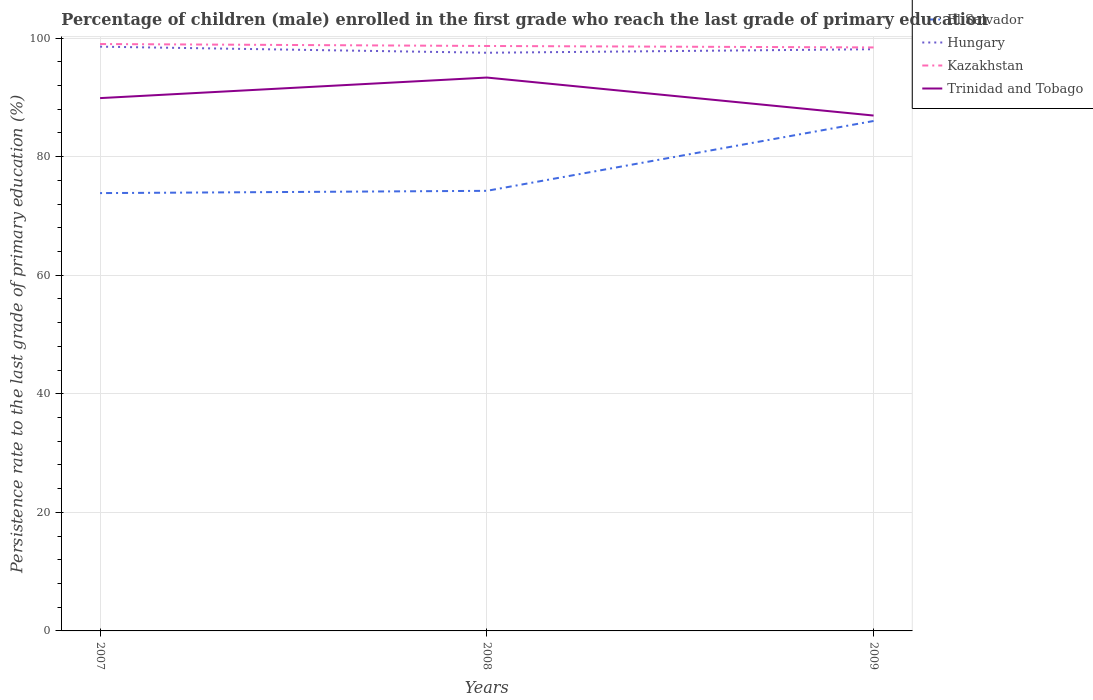How many different coloured lines are there?
Offer a terse response. 4. Does the line corresponding to El Salvador intersect with the line corresponding to Trinidad and Tobago?
Your answer should be compact. No. Across all years, what is the maximum persistence rate of children in Hungary?
Your response must be concise. 97.53. What is the total persistence rate of children in Kazakhstan in the graph?
Ensure brevity in your answer.  0.25. What is the difference between the highest and the second highest persistence rate of children in Kazakhstan?
Give a very brief answer. 0.57. Are the values on the major ticks of Y-axis written in scientific E-notation?
Ensure brevity in your answer.  No. Does the graph contain any zero values?
Offer a terse response. No. What is the title of the graph?
Make the answer very short. Percentage of children (male) enrolled in the first grade who reach the last grade of primary education. Does "Malta" appear as one of the legend labels in the graph?
Offer a very short reply. No. What is the label or title of the X-axis?
Provide a short and direct response. Years. What is the label or title of the Y-axis?
Ensure brevity in your answer.  Persistence rate to the last grade of primary education (%). What is the Persistence rate to the last grade of primary education (%) in El Salvador in 2007?
Your response must be concise. 73.85. What is the Persistence rate to the last grade of primary education (%) in Hungary in 2007?
Make the answer very short. 98.56. What is the Persistence rate to the last grade of primary education (%) in Kazakhstan in 2007?
Offer a very short reply. 99. What is the Persistence rate to the last grade of primary education (%) in Trinidad and Tobago in 2007?
Your answer should be very brief. 89.88. What is the Persistence rate to the last grade of primary education (%) of El Salvador in 2008?
Your answer should be very brief. 74.24. What is the Persistence rate to the last grade of primary education (%) in Hungary in 2008?
Give a very brief answer. 97.53. What is the Persistence rate to the last grade of primary education (%) of Kazakhstan in 2008?
Keep it short and to the point. 98.67. What is the Persistence rate to the last grade of primary education (%) in Trinidad and Tobago in 2008?
Make the answer very short. 93.35. What is the Persistence rate to the last grade of primary education (%) of El Salvador in 2009?
Give a very brief answer. 86.02. What is the Persistence rate to the last grade of primary education (%) of Hungary in 2009?
Ensure brevity in your answer.  98.12. What is the Persistence rate to the last grade of primary education (%) in Kazakhstan in 2009?
Offer a terse response. 98.42. What is the Persistence rate to the last grade of primary education (%) in Trinidad and Tobago in 2009?
Your answer should be very brief. 86.94. Across all years, what is the maximum Persistence rate to the last grade of primary education (%) of El Salvador?
Your response must be concise. 86.02. Across all years, what is the maximum Persistence rate to the last grade of primary education (%) of Hungary?
Give a very brief answer. 98.56. Across all years, what is the maximum Persistence rate to the last grade of primary education (%) in Kazakhstan?
Offer a very short reply. 99. Across all years, what is the maximum Persistence rate to the last grade of primary education (%) in Trinidad and Tobago?
Give a very brief answer. 93.35. Across all years, what is the minimum Persistence rate to the last grade of primary education (%) of El Salvador?
Your answer should be very brief. 73.85. Across all years, what is the minimum Persistence rate to the last grade of primary education (%) in Hungary?
Ensure brevity in your answer.  97.53. Across all years, what is the minimum Persistence rate to the last grade of primary education (%) of Kazakhstan?
Your answer should be very brief. 98.42. Across all years, what is the minimum Persistence rate to the last grade of primary education (%) in Trinidad and Tobago?
Offer a very short reply. 86.94. What is the total Persistence rate to the last grade of primary education (%) in El Salvador in the graph?
Offer a very short reply. 234.11. What is the total Persistence rate to the last grade of primary education (%) of Hungary in the graph?
Make the answer very short. 294.21. What is the total Persistence rate to the last grade of primary education (%) of Kazakhstan in the graph?
Provide a short and direct response. 296.09. What is the total Persistence rate to the last grade of primary education (%) of Trinidad and Tobago in the graph?
Offer a very short reply. 270.16. What is the difference between the Persistence rate to the last grade of primary education (%) in El Salvador in 2007 and that in 2008?
Ensure brevity in your answer.  -0.38. What is the difference between the Persistence rate to the last grade of primary education (%) of Hungary in 2007 and that in 2008?
Keep it short and to the point. 1.03. What is the difference between the Persistence rate to the last grade of primary education (%) of Kazakhstan in 2007 and that in 2008?
Offer a terse response. 0.33. What is the difference between the Persistence rate to the last grade of primary education (%) in Trinidad and Tobago in 2007 and that in 2008?
Keep it short and to the point. -3.47. What is the difference between the Persistence rate to the last grade of primary education (%) in El Salvador in 2007 and that in 2009?
Your answer should be very brief. -12.16. What is the difference between the Persistence rate to the last grade of primary education (%) of Hungary in 2007 and that in 2009?
Provide a short and direct response. 0.43. What is the difference between the Persistence rate to the last grade of primary education (%) in Kazakhstan in 2007 and that in 2009?
Your answer should be compact. 0.57. What is the difference between the Persistence rate to the last grade of primary education (%) in Trinidad and Tobago in 2007 and that in 2009?
Your response must be concise. 2.94. What is the difference between the Persistence rate to the last grade of primary education (%) of El Salvador in 2008 and that in 2009?
Your answer should be very brief. -11.78. What is the difference between the Persistence rate to the last grade of primary education (%) in Hungary in 2008 and that in 2009?
Your answer should be compact. -0.59. What is the difference between the Persistence rate to the last grade of primary education (%) of Kazakhstan in 2008 and that in 2009?
Keep it short and to the point. 0.25. What is the difference between the Persistence rate to the last grade of primary education (%) of Trinidad and Tobago in 2008 and that in 2009?
Give a very brief answer. 6.41. What is the difference between the Persistence rate to the last grade of primary education (%) in El Salvador in 2007 and the Persistence rate to the last grade of primary education (%) in Hungary in 2008?
Provide a succinct answer. -23.68. What is the difference between the Persistence rate to the last grade of primary education (%) in El Salvador in 2007 and the Persistence rate to the last grade of primary education (%) in Kazakhstan in 2008?
Keep it short and to the point. -24.82. What is the difference between the Persistence rate to the last grade of primary education (%) in El Salvador in 2007 and the Persistence rate to the last grade of primary education (%) in Trinidad and Tobago in 2008?
Your answer should be very brief. -19.49. What is the difference between the Persistence rate to the last grade of primary education (%) of Hungary in 2007 and the Persistence rate to the last grade of primary education (%) of Kazakhstan in 2008?
Offer a very short reply. -0.12. What is the difference between the Persistence rate to the last grade of primary education (%) of Hungary in 2007 and the Persistence rate to the last grade of primary education (%) of Trinidad and Tobago in 2008?
Keep it short and to the point. 5.21. What is the difference between the Persistence rate to the last grade of primary education (%) in Kazakhstan in 2007 and the Persistence rate to the last grade of primary education (%) in Trinidad and Tobago in 2008?
Provide a short and direct response. 5.65. What is the difference between the Persistence rate to the last grade of primary education (%) in El Salvador in 2007 and the Persistence rate to the last grade of primary education (%) in Hungary in 2009?
Offer a terse response. -24.27. What is the difference between the Persistence rate to the last grade of primary education (%) of El Salvador in 2007 and the Persistence rate to the last grade of primary education (%) of Kazakhstan in 2009?
Ensure brevity in your answer.  -24.57. What is the difference between the Persistence rate to the last grade of primary education (%) in El Salvador in 2007 and the Persistence rate to the last grade of primary education (%) in Trinidad and Tobago in 2009?
Provide a short and direct response. -13.08. What is the difference between the Persistence rate to the last grade of primary education (%) of Hungary in 2007 and the Persistence rate to the last grade of primary education (%) of Kazakhstan in 2009?
Ensure brevity in your answer.  0.13. What is the difference between the Persistence rate to the last grade of primary education (%) of Hungary in 2007 and the Persistence rate to the last grade of primary education (%) of Trinidad and Tobago in 2009?
Your answer should be compact. 11.62. What is the difference between the Persistence rate to the last grade of primary education (%) in Kazakhstan in 2007 and the Persistence rate to the last grade of primary education (%) in Trinidad and Tobago in 2009?
Keep it short and to the point. 12.06. What is the difference between the Persistence rate to the last grade of primary education (%) in El Salvador in 2008 and the Persistence rate to the last grade of primary education (%) in Hungary in 2009?
Your response must be concise. -23.89. What is the difference between the Persistence rate to the last grade of primary education (%) of El Salvador in 2008 and the Persistence rate to the last grade of primary education (%) of Kazakhstan in 2009?
Keep it short and to the point. -24.19. What is the difference between the Persistence rate to the last grade of primary education (%) of El Salvador in 2008 and the Persistence rate to the last grade of primary education (%) of Trinidad and Tobago in 2009?
Offer a very short reply. -12.7. What is the difference between the Persistence rate to the last grade of primary education (%) of Hungary in 2008 and the Persistence rate to the last grade of primary education (%) of Kazakhstan in 2009?
Provide a short and direct response. -0.89. What is the difference between the Persistence rate to the last grade of primary education (%) of Hungary in 2008 and the Persistence rate to the last grade of primary education (%) of Trinidad and Tobago in 2009?
Keep it short and to the point. 10.59. What is the difference between the Persistence rate to the last grade of primary education (%) of Kazakhstan in 2008 and the Persistence rate to the last grade of primary education (%) of Trinidad and Tobago in 2009?
Your answer should be compact. 11.73. What is the average Persistence rate to the last grade of primary education (%) in El Salvador per year?
Your answer should be compact. 78.04. What is the average Persistence rate to the last grade of primary education (%) in Hungary per year?
Provide a succinct answer. 98.07. What is the average Persistence rate to the last grade of primary education (%) of Kazakhstan per year?
Offer a very short reply. 98.7. What is the average Persistence rate to the last grade of primary education (%) of Trinidad and Tobago per year?
Provide a succinct answer. 90.05. In the year 2007, what is the difference between the Persistence rate to the last grade of primary education (%) of El Salvador and Persistence rate to the last grade of primary education (%) of Hungary?
Offer a terse response. -24.7. In the year 2007, what is the difference between the Persistence rate to the last grade of primary education (%) in El Salvador and Persistence rate to the last grade of primary education (%) in Kazakhstan?
Your answer should be compact. -25.15. In the year 2007, what is the difference between the Persistence rate to the last grade of primary education (%) in El Salvador and Persistence rate to the last grade of primary education (%) in Trinidad and Tobago?
Make the answer very short. -16.02. In the year 2007, what is the difference between the Persistence rate to the last grade of primary education (%) in Hungary and Persistence rate to the last grade of primary education (%) in Kazakhstan?
Offer a very short reply. -0.44. In the year 2007, what is the difference between the Persistence rate to the last grade of primary education (%) of Hungary and Persistence rate to the last grade of primary education (%) of Trinidad and Tobago?
Your answer should be very brief. 8.68. In the year 2007, what is the difference between the Persistence rate to the last grade of primary education (%) in Kazakhstan and Persistence rate to the last grade of primary education (%) in Trinidad and Tobago?
Ensure brevity in your answer.  9.12. In the year 2008, what is the difference between the Persistence rate to the last grade of primary education (%) in El Salvador and Persistence rate to the last grade of primary education (%) in Hungary?
Your answer should be very brief. -23.29. In the year 2008, what is the difference between the Persistence rate to the last grade of primary education (%) of El Salvador and Persistence rate to the last grade of primary education (%) of Kazakhstan?
Ensure brevity in your answer.  -24.43. In the year 2008, what is the difference between the Persistence rate to the last grade of primary education (%) of El Salvador and Persistence rate to the last grade of primary education (%) of Trinidad and Tobago?
Ensure brevity in your answer.  -19.11. In the year 2008, what is the difference between the Persistence rate to the last grade of primary education (%) of Hungary and Persistence rate to the last grade of primary education (%) of Kazakhstan?
Your response must be concise. -1.14. In the year 2008, what is the difference between the Persistence rate to the last grade of primary education (%) of Hungary and Persistence rate to the last grade of primary education (%) of Trinidad and Tobago?
Make the answer very short. 4.18. In the year 2008, what is the difference between the Persistence rate to the last grade of primary education (%) of Kazakhstan and Persistence rate to the last grade of primary education (%) of Trinidad and Tobago?
Your answer should be compact. 5.32. In the year 2009, what is the difference between the Persistence rate to the last grade of primary education (%) of El Salvador and Persistence rate to the last grade of primary education (%) of Hungary?
Keep it short and to the point. -12.11. In the year 2009, what is the difference between the Persistence rate to the last grade of primary education (%) in El Salvador and Persistence rate to the last grade of primary education (%) in Kazakhstan?
Provide a succinct answer. -12.41. In the year 2009, what is the difference between the Persistence rate to the last grade of primary education (%) of El Salvador and Persistence rate to the last grade of primary education (%) of Trinidad and Tobago?
Provide a short and direct response. -0.92. In the year 2009, what is the difference between the Persistence rate to the last grade of primary education (%) of Hungary and Persistence rate to the last grade of primary education (%) of Kazakhstan?
Give a very brief answer. -0.3. In the year 2009, what is the difference between the Persistence rate to the last grade of primary education (%) in Hungary and Persistence rate to the last grade of primary education (%) in Trinidad and Tobago?
Keep it short and to the point. 11.19. In the year 2009, what is the difference between the Persistence rate to the last grade of primary education (%) of Kazakhstan and Persistence rate to the last grade of primary education (%) of Trinidad and Tobago?
Your response must be concise. 11.49. What is the ratio of the Persistence rate to the last grade of primary education (%) in Hungary in 2007 to that in 2008?
Your answer should be very brief. 1.01. What is the ratio of the Persistence rate to the last grade of primary education (%) of Trinidad and Tobago in 2007 to that in 2008?
Ensure brevity in your answer.  0.96. What is the ratio of the Persistence rate to the last grade of primary education (%) in El Salvador in 2007 to that in 2009?
Ensure brevity in your answer.  0.86. What is the ratio of the Persistence rate to the last grade of primary education (%) of Hungary in 2007 to that in 2009?
Keep it short and to the point. 1. What is the ratio of the Persistence rate to the last grade of primary education (%) of Kazakhstan in 2007 to that in 2009?
Your answer should be compact. 1.01. What is the ratio of the Persistence rate to the last grade of primary education (%) in Trinidad and Tobago in 2007 to that in 2009?
Give a very brief answer. 1.03. What is the ratio of the Persistence rate to the last grade of primary education (%) of El Salvador in 2008 to that in 2009?
Offer a terse response. 0.86. What is the ratio of the Persistence rate to the last grade of primary education (%) of Hungary in 2008 to that in 2009?
Provide a succinct answer. 0.99. What is the ratio of the Persistence rate to the last grade of primary education (%) of Trinidad and Tobago in 2008 to that in 2009?
Your response must be concise. 1.07. What is the difference between the highest and the second highest Persistence rate to the last grade of primary education (%) in El Salvador?
Give a very brief answer. 11.78. What is the difference between the highest and the second highest Persistence rate to the last grade of primary education (%) in Hungary?
Your answer should be very brief. 0.43. What is the difference between the highest and the second highest Persistence rate to the last grade of primary education (%) of Kazakhstan?
Provide a short and direct response. 0.33. What is the difference between the highest and the second highest Persistence rate to the last grade of primary education (%) of Trinidad and Tobago?
Provide a short and direct response. 3.47. What is the difference between the highest and the lowest Persistence rate to the last grade of primary education (%) of El Salvador?
Offer a terse response. 12.16. What is the difference between the highest and the lowest Persistence rate to the last grade of primary education (%) of Hungary?
Your answer should be compact. 1.03. What is the difference between the highest and the lowest Persistence rate to the last grade of primary education (%) of Kazakhstan?
Provide a succinct answer. 0.57. What is the difference between the highest and the lowest Persistence rate to the last grade of primary education (%) in Trinidad and Tobago?
Offer a very short reply. 6.41. 